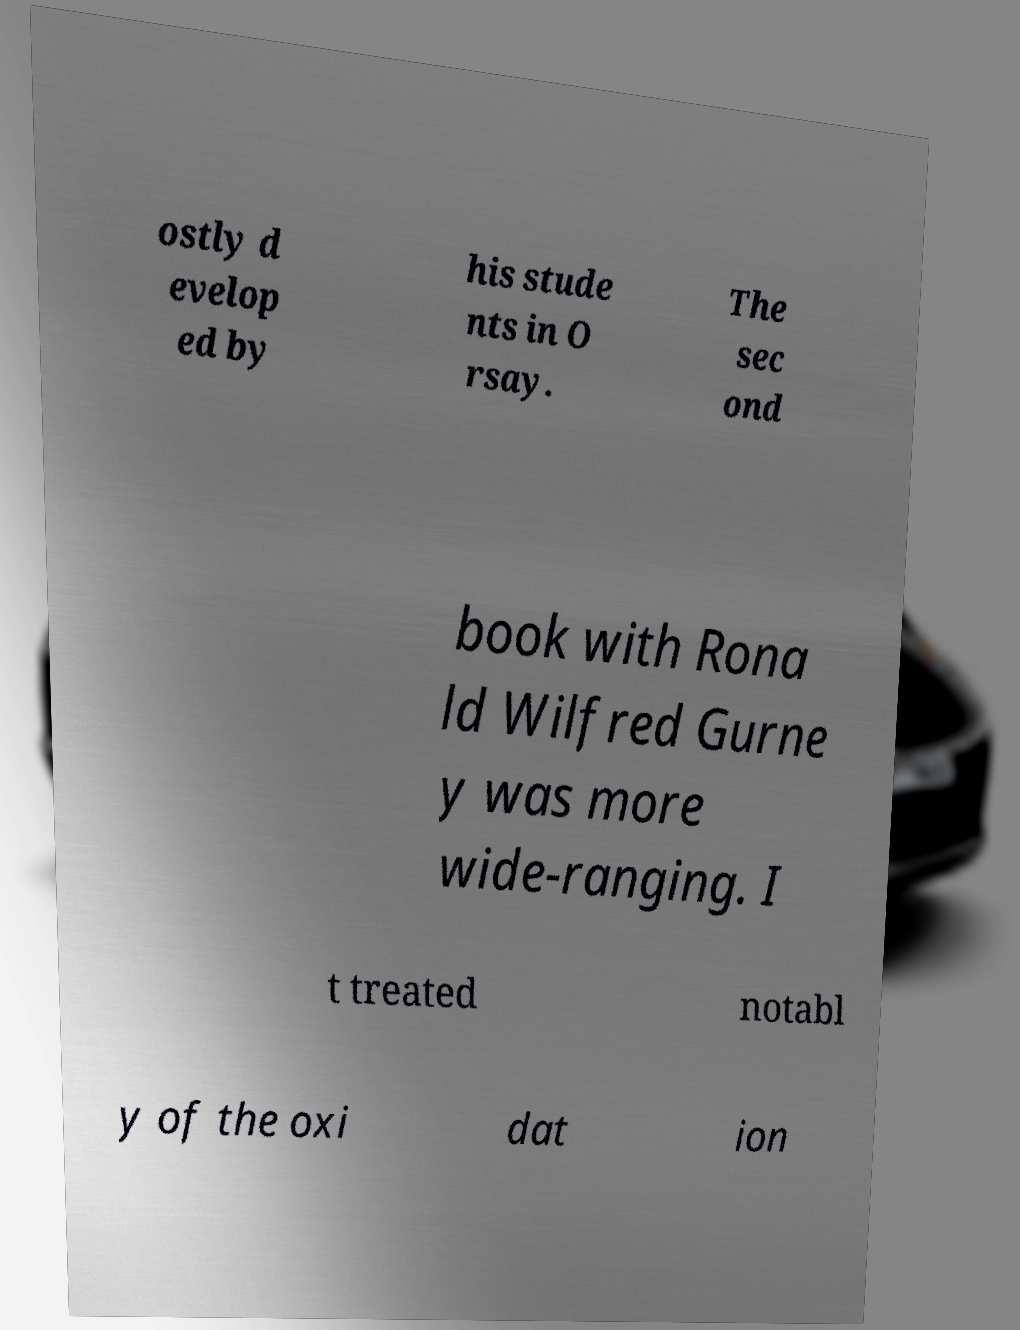Could you assist in decoding the text presented in this image and type it out clearly? ostly d evelop ed by his stude nts in O rsay. The sec ond book with Rona ld Wilfred Gurne y was more wide-ranging. I t treated notabl y of the oxi dat ion 